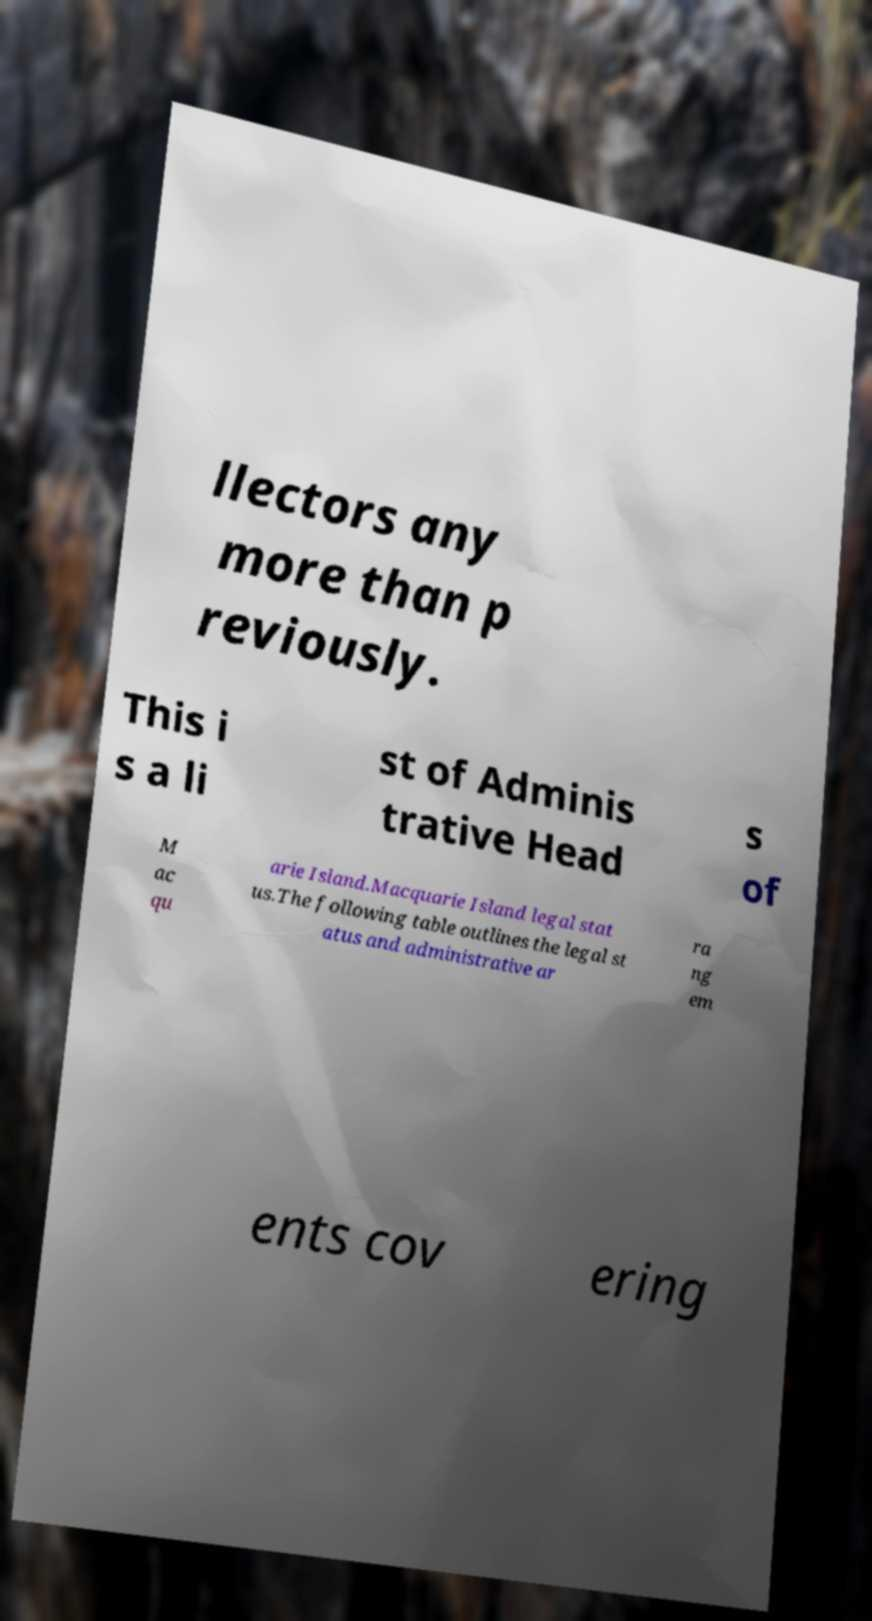There's text embedded in this image that I need extracted. Can you transcribe it verbatim? llectors any more than p reviously. This i s a li st of Adminis trative Head s of M ac qu arie Island.Macquarie Island legal stat us.The following table outlines the legal st atus and administrative ar ra ng em ents cov ering 